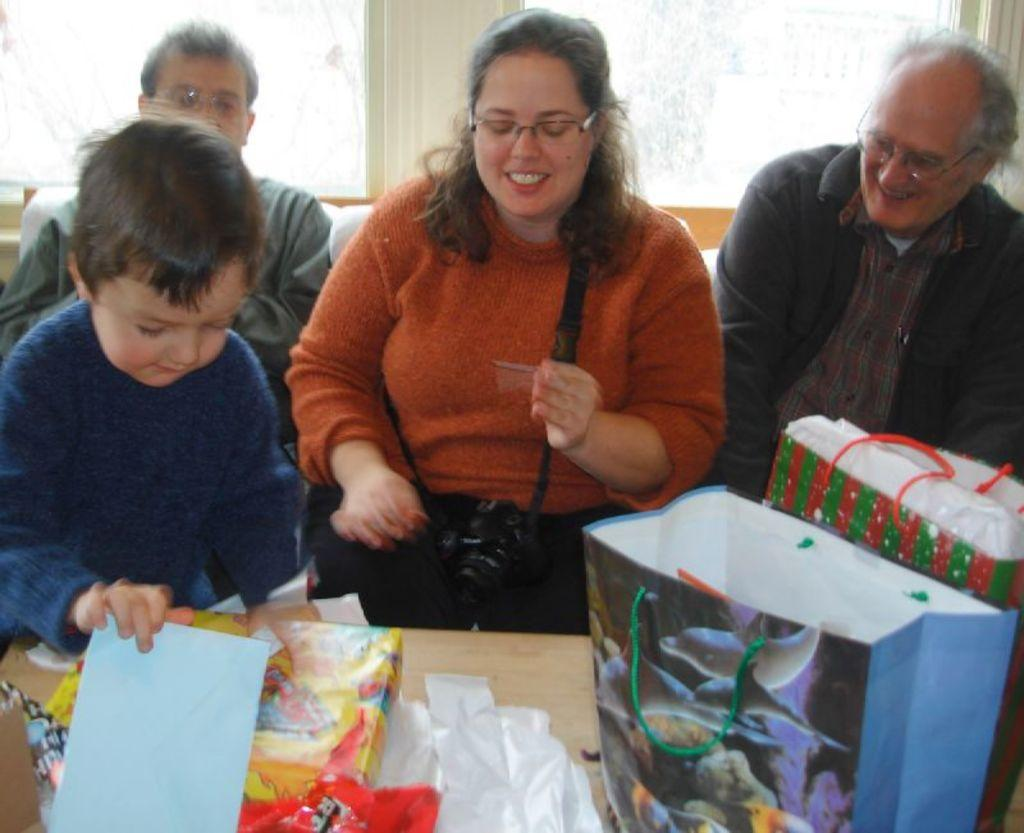How many people are present in the image? There are 4 people in the image. What are the people doing in the image? The people are sitting in a room. What objects can be seen in front of the people? There are carry bags and gifts in front of the people. Can you describe the room where the people are sitting? There is a window in the room. What type of pancake is being used as a treatment for the people in the image? There is no pancake present in the image, and no treatment is being administered to the people. How many kicks can be seen in the image? There are no kicks visible in the image. 